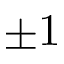<formula> <loc_0><loc_0><loc_500><loc_500>\pm 1</formula> 